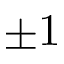<formula> <loc_0><loc_0><loc_500><loc_500>\pm 1</formula> 